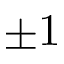<formula> <loc_0><loc_0><loc_500><loc_500>\pm 1</formula> 